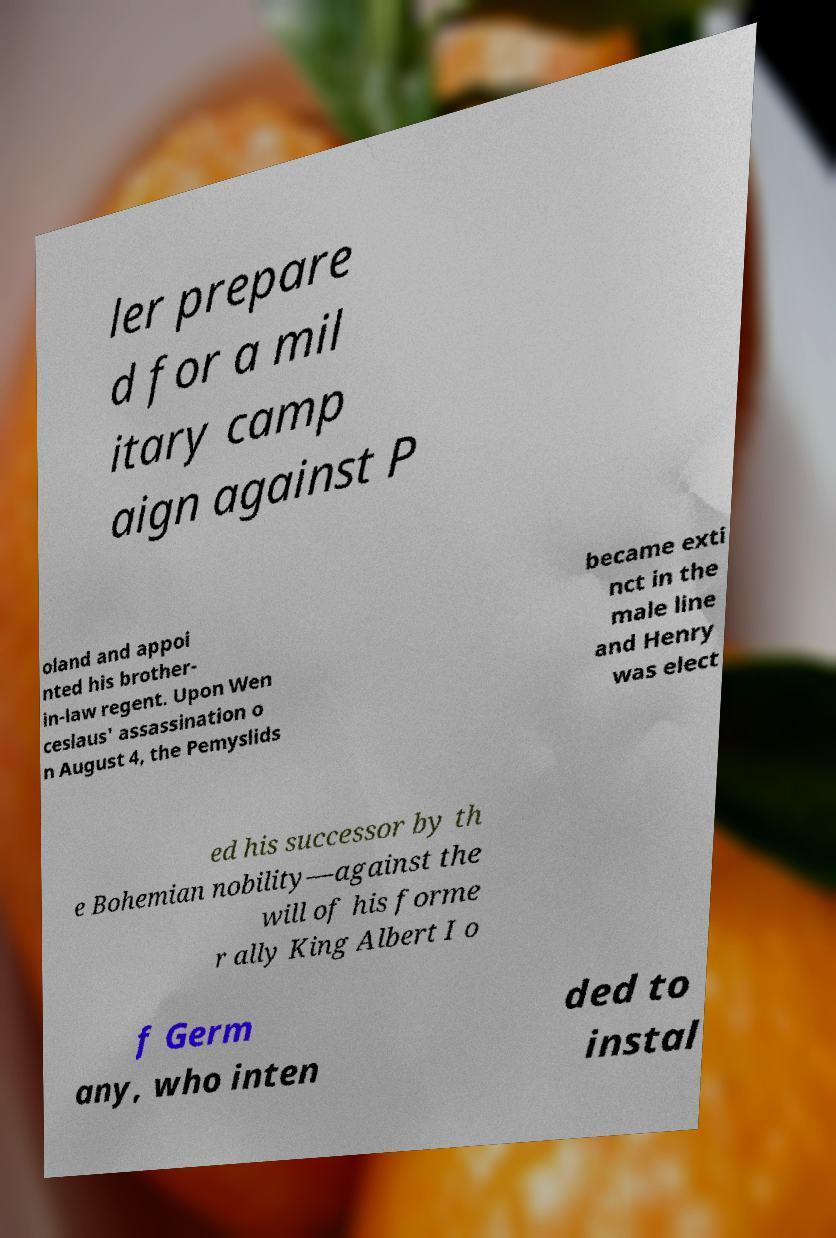Please read and relay the text visible in this image. What does it say? ler prepare d for a mil itary camp aign against P oland and appoi nted his brother- in-law regent. Upon Wen ceslaus' assassination o n August 4, the Pemyslids became exti nct in the male line and Henry was elect ed his successor by th e Bohemian nobility—against the will of his forme r ally King Albert I o f Germ any, who inten ded to instal 